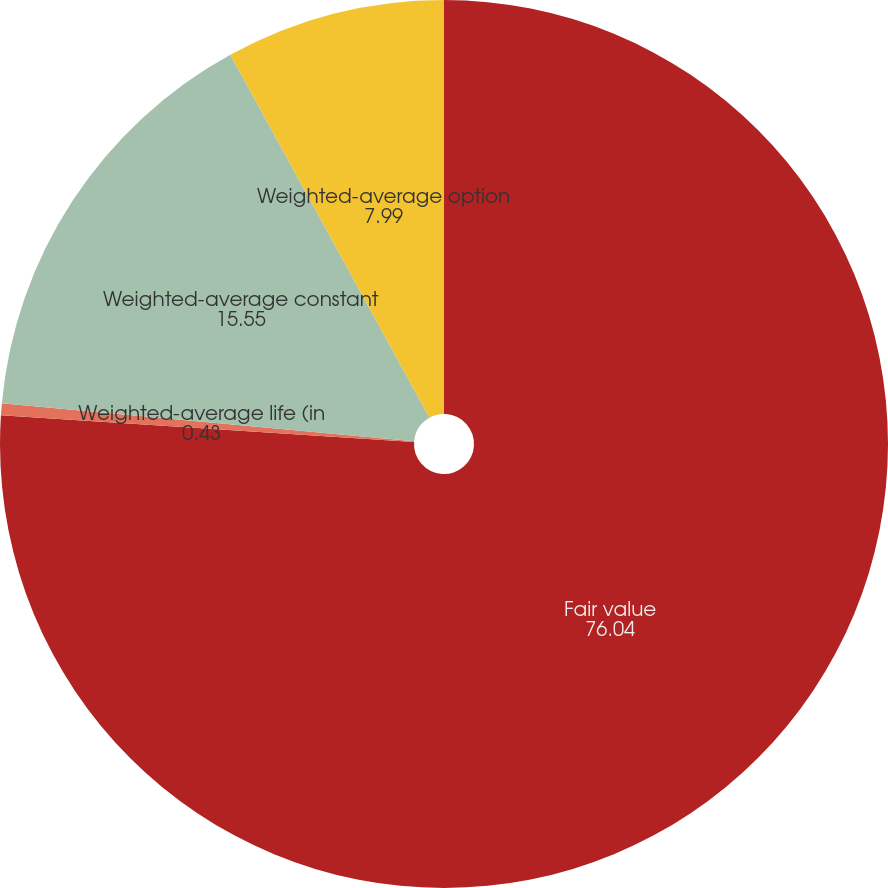Convert chart to OTSL. <chart><loc_0><loc_0><loc_500><loc_500><pie_chart><fcel>Fair value<fcel>Weighted-average life (in<fcel>Weighted-average constant<fcel>Weighted-average option<nl><fcel>76.04%<fcel>0.43%<fcel>15.55%<fcel>7.99%<nl></chart> 